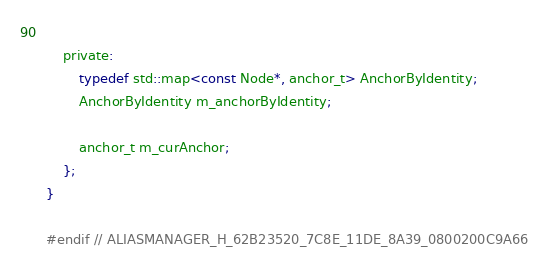Convert code to text. <code><loc_0><loc_0><loc_500><loc_500><_C_>		
	private:
		typedef std::map<const Node*, anchor_t> AnchorByIdentity;
		AnchorByIdentity m_anchorByIdentity;
		
		anchor_t m_curAnchor;
	};
}

#endif // ALIASMANAGER_H_62B23520_7C8E_11DE_8A39_0800200C9A66
</code> 